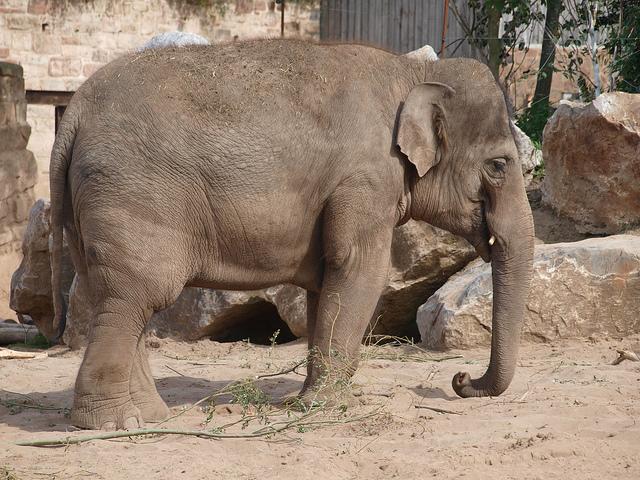Is he in his natural environment?
Write a very short answer. No. Is this an Asian elephant?
Quick response, please. Yes. Is the elephant drinking water?
Write a very short answer. No. What is on the elephant's back?
Answer briefly. Hair. How many adults elephants in this photo?
Quick response, please. 1. 